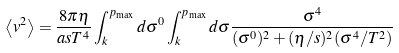Convert formula to latex. <formula><loc_0><loc_0><loc_500><loc_500>\left \langle v ^ { 2 } \right \rangle = \frac { 8 \pi \eta } { a s T ^ { 4 } } \int _ { k } ^ { p _ { \max } } d \sigma ^ { 0 } \int _ { k } ^ { p _ { \max } } d \sigma \frac { \sigma ^ { 4 } } { ( \sigma ^ { 0 } ) ^ { 2 } + ( \eta / s ) ^ { 2 } ( \sigma ^ { 4 } / T ^ { 2 } ) }</formula> 